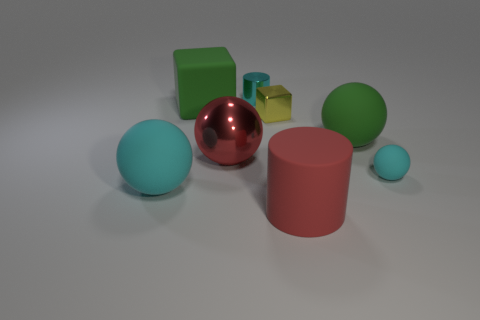Subtract all big cyan spheres. How many spheres are left? 3 Subtract all blue cylinders. How many cyan balls are left? 2 Subtract 2 balls. How many balls are left? 2 Subtract all green balls. How many balls are left? 3 Add 2 gray spheres. How many objects exist? 10 Subtract all green spheres. Subtract all red cylinders. How many spheres are left? 3 Subtract all cubes. How many objects are left? 6 Subtract 1 red balls. How many objects are left? 7 Subtract all cyan metallic cylinders. Subtract all big metallic things. How many objects are left? 6 Add 7 green rubber things. How many green rubber things are left? 9 